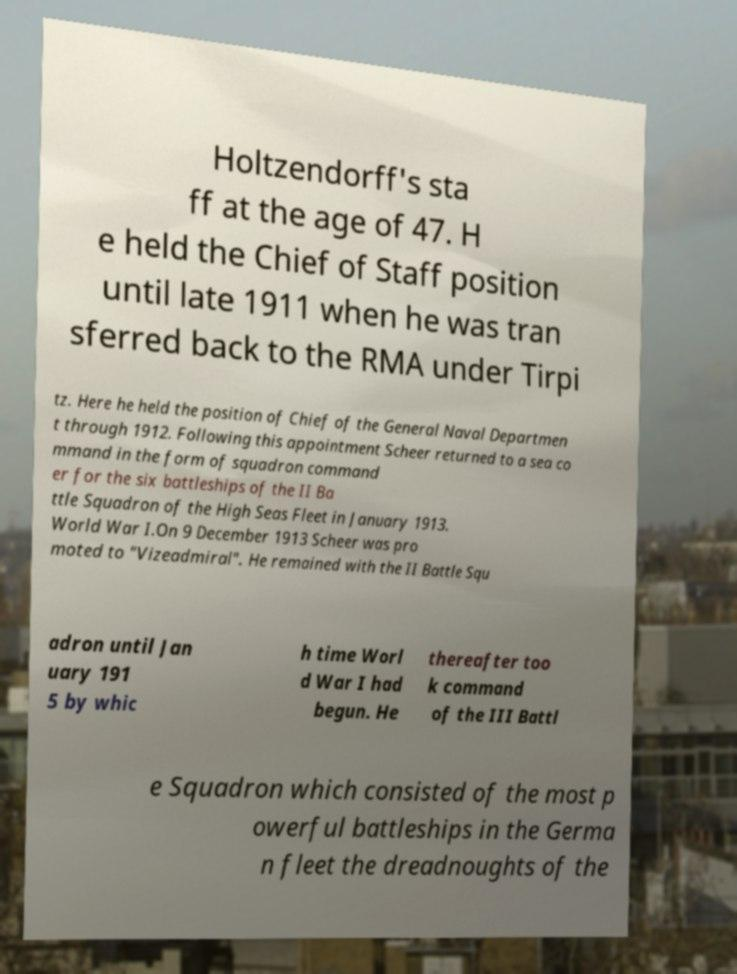Please identify and transcribe the text found in this image. Holtzendorff's sta ff at the age of 47. H e held the Chief of Staff position until late 1911 when he was tran sferred back to the RMA under Tirpi tz. Here he held the position of Chief of the General Naval Departmen t through 1912. Following this appointment Scheer returned to a sea co mmand in the form of squadron command er for the six battleships of the II Ba ttle Squadron of the High Seas Fleet in January 1913. World War I.On 9 December 1913 Scheer was pro moted to "Vizeadmiral". He remained with the II Battle Squ adron until Jan uary 191 5 by whic h time Worl d War I had begun. He thereafter too k command of the III Battl e Squadron which consisted of the most p owerful battleships in the Germa n fleet the dreadnoughts of the 